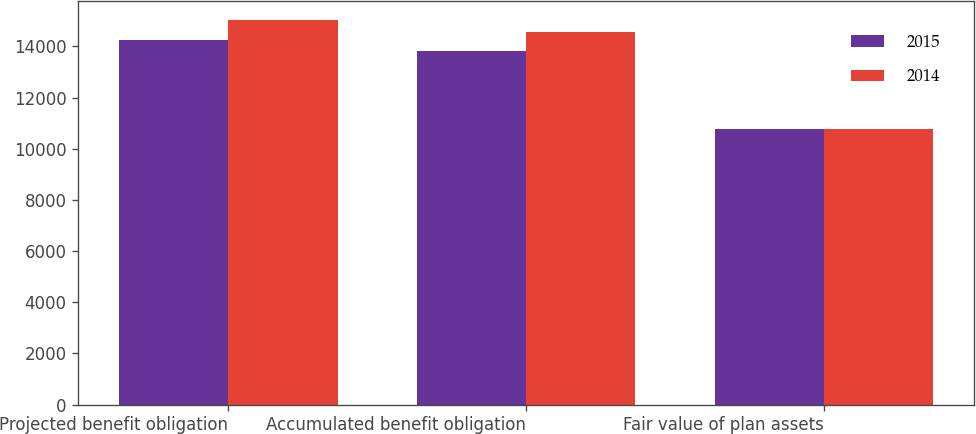Convert chart. <chart><loc_0><loc_0><loc_500><loc_500><stacked_bar_chart><ecel><fcel>Projected benefit obligation<fcel>Accumulated benefit obligation<fcel>Fair value of plan assets<nl><fcel>2015<fcel>14247<fcel>13832<fcel>10786<nl><fcel>2014<fcel>15019<fcel>14553<fcel>10777<nl></chart> 